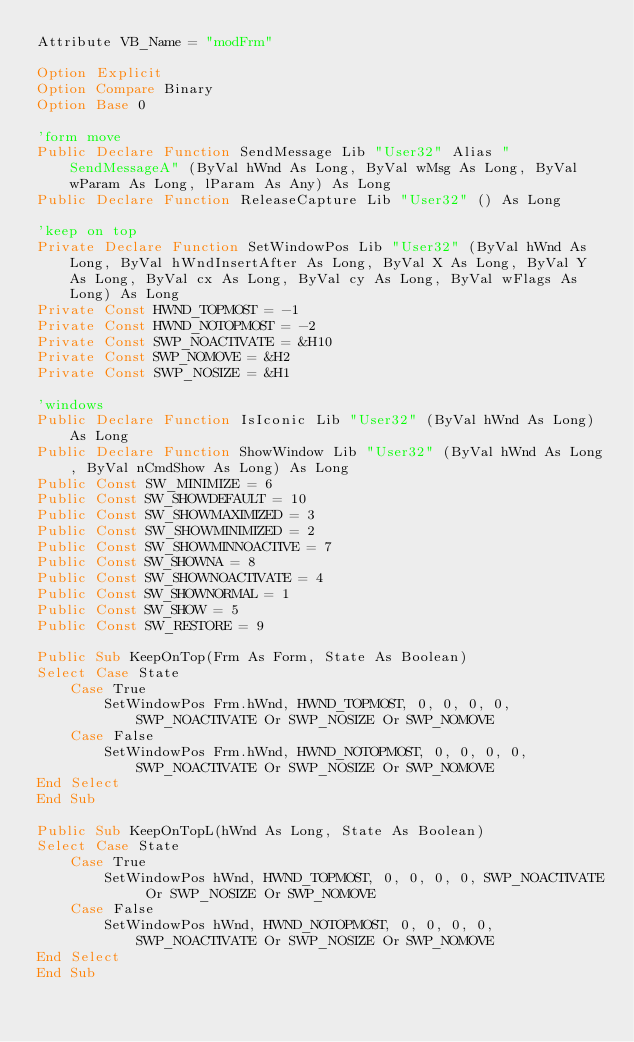<code> <loc_0><loc_0><loc_500><loc_500><_VisualBasic_>Attribute VB_Name = "modFrm"

Option Explicit
Option Compare Binary
Option Base 0

'form move
Public Declare Function SendMessage Lib "User32" Alias "SendMessageA" (ByVal hWnd As Long, ByVal wMsg As Long, ByVal wParam As Long, lParam As Any) As Long
Public Declare Function ReleaseCapture Lib "User32" () As Long

'keep on top
Private Declare Function SetWindowPos Lib "User32" (ByVal hWnd As Long, ByVal hWndInsertAfter As Long, ByVal X As Long, ByVal Y As Long, ByVal cx As Long, ByVal cy As Long, ByVal wFlags As Long) As Long
Private Const HWND_TOPMOST = -1
Private Const HWND_NOTOPMOST = -2
Private Const SWP_NOACTIVATE = &H10
Private Const SWP_NOMOVE = &H2
Private Const SWP_NOSIZE = &H1

'windows
Public Declare Function IsIconic Lib "User32" (ByVal hWnd As Long) As Long
Public Declare Function ShowWindow Lib "User32" (ByVal hWnd As Long, ByVal nCmdShow As Long) As Long
Public Const SW_MINIMIZE = 6
Public Const SW_SHOWDEFAULT = 10
Public Const SW_SHOWMAXIMIZED = 3
Public Const SW_SHOWMINIMIZED = 2
Public Const SW_SHOWMINNOACTIVE = 7
Public Const SW_SHOWNA = 8
Public Const SW_SHOWNOACTIVATE = 4
Public Const SW_SHOWNORMAL = 1
Public Const SW_SHOW = 5
Public Const SW_RESTORE = 9

Public Sub KeepOnTop(Frm As Form, State As Boolean)
Select Case State
    Case True
        SetWindowPos Frm.hWnd, HWND_TOPMOST, 0, 0, 0, 0, SWP_NOACTIVATE Or SWP_NOSIZE Or SWP_NOMOVE
    Case False
        SetWindowPos Frm.hWnd, HWND_NOTOPMOST, 0, 0, 0, 0, SWP_NOACTIVATE Or SWP_NOSIZE Or SWP_NOMOVE
End Select
End Sub

Public Sub KeepOnTopL(hWnd As Long, State As Boolean)
Select Case State
    Case True
        SetWindowPos hWnd, HWND_TOPMOST, 0, 0, 0, 0, SWP_NOACTIVATE Or SWP_NOSIZE Or SWP_NOMOVE
    Case False
        SetWindowPos hWnd, HWND_NOTOPMOST, 0, 0, 0, 0, SWP_NOACTIVATE Or SWP_NOSIZE Or SWP_NOMOVE
End Select
End Sub
</code> 